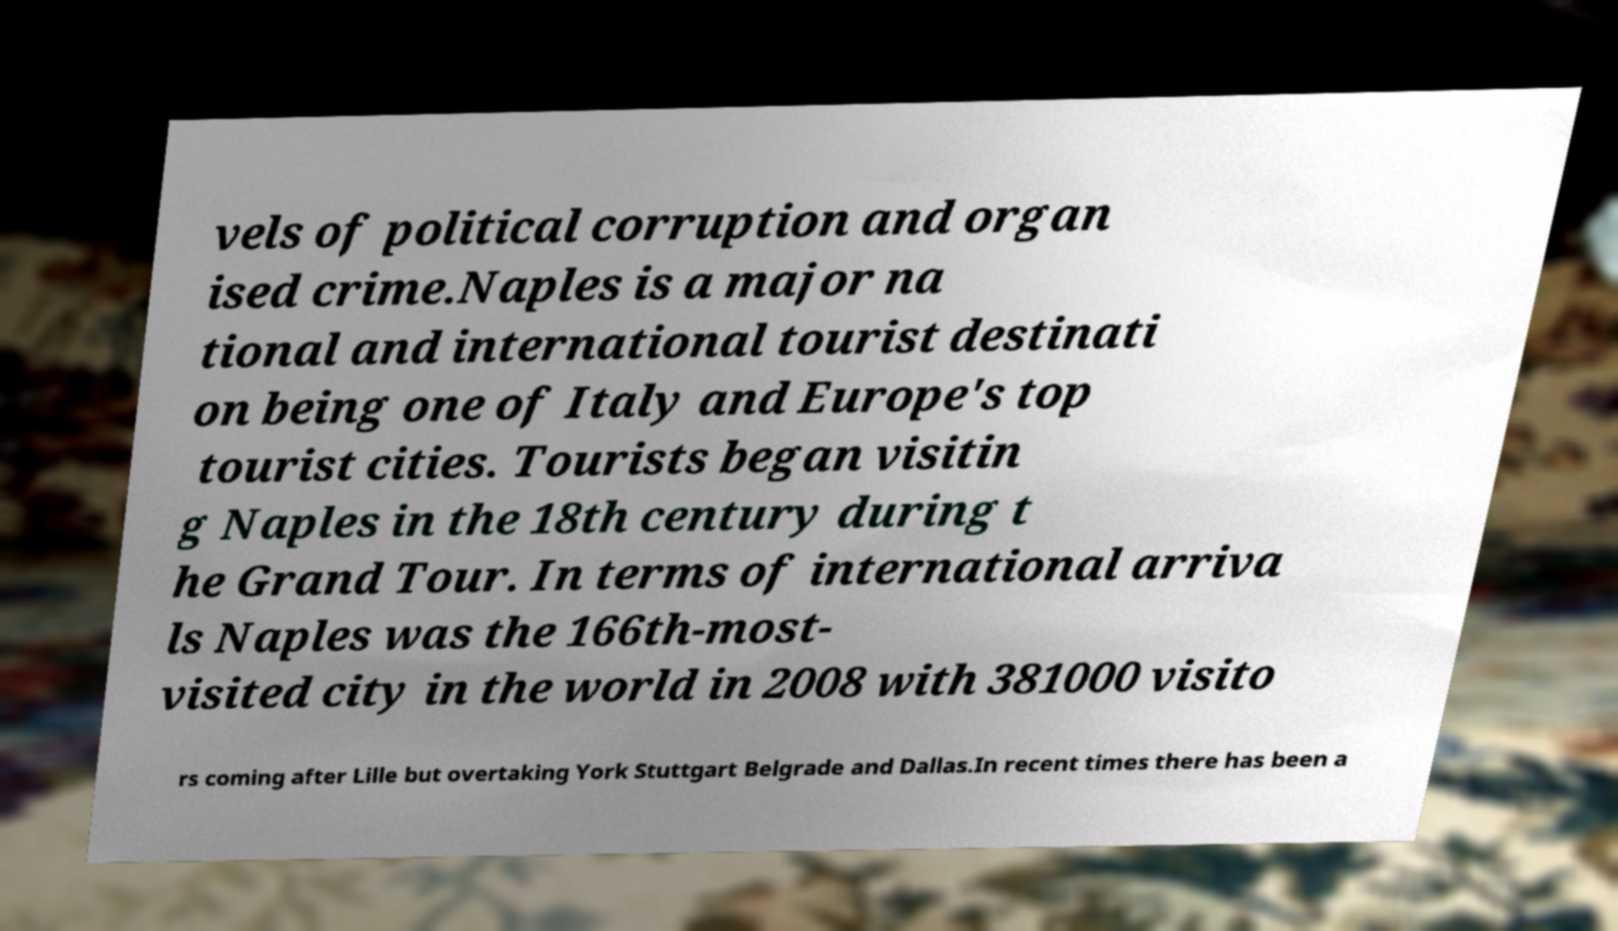Can you accurately transcribe the text from the provided image for me? vels of political corruption and organ ised crime.Naples is a major na tional and international tourist destinati on being one of Italy and Europe's top tourist cities. Tourists began visitin g Naples in the 18th century during t he Grand Tour. In terms of international arriva ls Naples was the 166th-most- visited city in the world in 2008 with 381000 visito rs coming after Lille but overtaking York Stuttgart Belgrade and Dallas.In recent times there has been a 